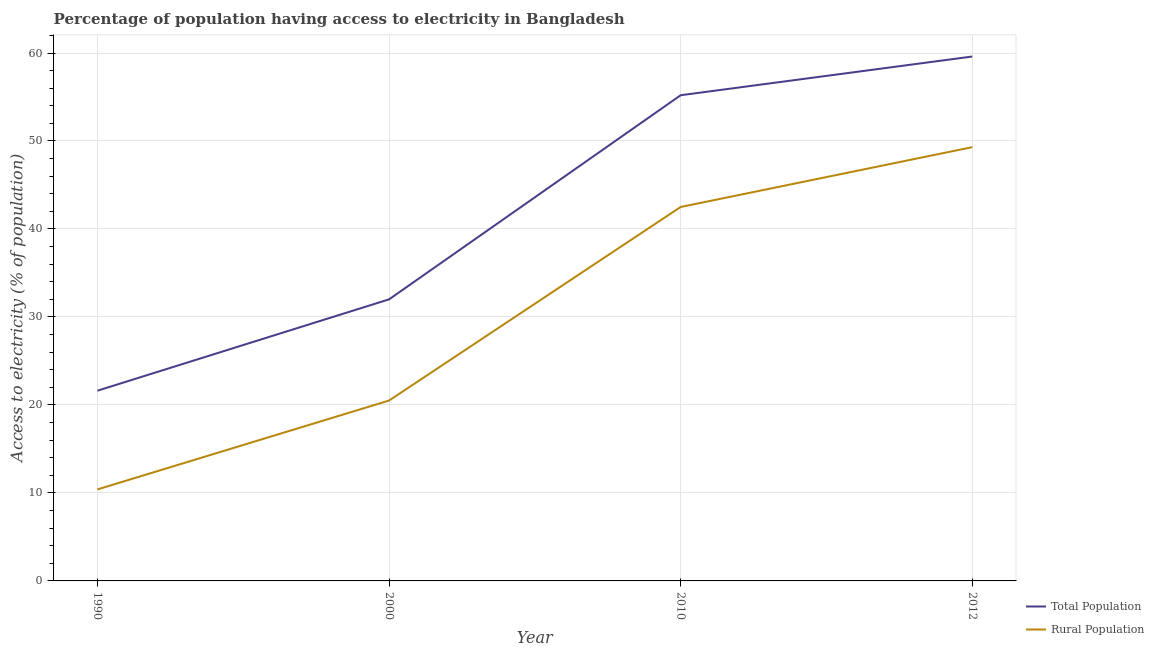Does the line corresponding to percentage of population having access to electricity intersect with the line corresponding to percentage of rural population having access to electricity?
Offer a very short reply. No. Is the number of lines equal to the number of legend labels?
Provide a short and direct response. Yes. Across all years, what is the maximum percentage of population having access to electricity?
Ensure brevity in your answer.  59.6. In which year was the percentage of rural population having access to electricity maximum?
Offer a terse response. 2012. In which year was the percentage of rural population having access to electricity minimum?
Make the answer very short. 1990. What is the total percentage of rural population having access to electricity in the graph?
Provide a short and direct response. 122.7. What is the difference between the percentage of population having access to electricity in 2010 and the percentage of rural population having access to electricity in 2000?
Offer a terse response. 34.7. What is the average percentage of population having access to electricity per year?
Make the answer very short. 42.11. In the year 1990, what is the difference between the percentage of population having access to electricity and percentage of rural population having access to electricity?
Ensure brevity in your answer.  11.22. In how many years, is the percentage of population having access to electricity greater than 16 %?
Keep it short and to the point. 4. What is the ratio of the percentage of rural population having access to electricity in 1990 to that in 2000?
Provide a succinct answer. 0.51. Is the percentage of rural population having access to electricity in 2000 less than that in 2010?
Provide a succinct answer. Yes. What is the difference between the highest and the second highest percentage of rural population having access to electricity?
Your answer should be very brief. 6.8. What is the difference between the highest and the lowest percentage of population having access to electricity?
Ensure brevity in your answer.  37.98. Does the percentage of population having access to electricity monotonically increase over the years?
Give a very brief answer. Yes. Is the percentage of population having access to electricity strictly less than the percentage of rural population having access to electricity over the years?
Make the answer very short. No. How many years are there in the graph?
Offer a terse response. 4. Does the graph contain any zero values?
Your response must be concise. No. How are the legend labels stacked?
Your answer should be very brief. Vertical. What is the title of the graph?
Your answer should be compact. Percentage of population having access to electricity in Bangladesh. Does "RDB nonconcessional" appear as one of the legend labels in the graph?
Make the answer very short. No. What is the label or title of the X-axis?
Ensure brevity in your answer.  Year. What is the label or title of the Y-axis?
Provide a succinct answer. Access to electricity (% of population). What is the Access to electricity (% of population) of Total Population in 1990?
Make the answer very short. 21.62. What is the Access to electricity (% of population) in Total Population in 2010?
Provide a short and direct response. 55.2. What is the Access to electricity (% of population) in Rural Population in 2010?
Make the answer very short. 42.5. What is the Access to electricity (% of population) in Total Population in 2012?
Offer a very short reply. 59.6. What is the Access to electricity (% of population) of Rural Population in 2012?
Give a very brief answer. 49.3. Across all years, what is the maximum Access to electricity (% of population) of Total Population?
Provide a succinct answer. 59.6. Across all years, what is the maximum Access to electricity (% of population) in Rural Population?
Your answer should be very brief. 49.3. Across all years, what is the minimum Access to electricity (% of population) of Total Population?
Keep it short and to the point. 21.62. Across all years, what is the minimum Access to electricity (% of population) of Rural Population?
Make the answer very short. 10.4. What is the total Access to electricity (% of population) in Total Population in the graph?
Your answer should be very brief. 168.42. What is the total Access to electricity (% of population) in Rural Population in the graph?
Your answer should be compact. 122.7. What is the difference between the Access to electricity (% of population) in Total Population in 1990 and that in 2000?
Ensure brevity in your answer.  -10.38. What is the difference between the Access to electricity (% of population) in Total Population in 1990 and that in 2010?
Provide a short and direct response. -33.58. What is the difference between the Access to electricity (% of population) of Rural Population in 1990 and that in 2010?
Keep it short and to the point. -32.1. What is the difference between the Access to electricity (% of population) of Total Population in 1990 and that in 2012?
Your answer should be compact. -37.98. What is the difference between the Access to electricity (% of population) of Rural Population in 1990 and that in 2012?
Make the answer very short. -38.9. What is the difference between the Access to electricity (% of population) of Total Population in 2000 and that in 2010?
Make the answer very short. -23.2. What is the difference between the Access to electricity (% of population) in Rural Population in 2000 and that in 2010?
Offer a very short reply. -22. What is the difference between the Access to electricity (% of population) of Total Population in 2000 and that in 2012?
Your answer should be very brief. -27.6. What is the difference between the Access to electricity (% of population) of Rural Population in 2000 and that in 2012?
Your answer should be very brief. -28.8. What is the difference between the Access to electricity (% of population) of Total Population in 2010 and that in 2012?
Offer a very short reply. -4.4. What is the difference between the Access to electricity (% of population) in Total Population in 1990 and the Access to electricity (% of population) in Rural Population in 2000?
Provide a succinct answer. 1.12. What is the difference between the Access to electricity (% of population) in Total Population in 1990 and the Access to electricity (% of population) in Rural Population in 2010?
Give a very brief answer. -20.88. What is the difference between the Access to electricity (% of population) of Total Population in 1990 and the Access to electricity (% of population) of Rural Population in 2012?
Offer a very short reply. -27.68. What is the difference between the Access to electricity (% of population) of Total Population in 2000 and the Access to electricity (% of population) of Rural Population in 2010?
Give a very brief answer. -10.5. What is the difference between the Access to electricity (% of population) of Total Population in 2000 and the Access to electricity (% of population) of Rural Population in 2012?
Ensure brevity in your answer.  -17.3. What is the average Access to electricity (% of population) in Total Population per year?
Your response must be concise. 42.1. What is the average Access to electricity (% of population) in Rural Population per year?
Provide a short and direct response. 30.68. In the year 1990, what is the difference between the Access to electricity (% of population) of Total Population and Access to electricity (% of population) of Rural Population?
Make the answer very short. 11.22. In the year 2000, what is the difference between the Access to electricity (% of population) of Total Population and Access to electricity (% of population) of Rural Population?
Your response must be concise. 11.5. What is the ratio of the Access to electricity (% of population) in Total Population in 1990 to that in 2000?
Provide a short and direct response. 0.68. What is the ratio of the Access to electricity (% of population) in Rural Population in 1990 to that in 2000?
Give a very brief answer. 0.51. What is the ratio of the Access to electricity (% of population) of Total Population in 1990 to that in 2010?
Your response must be concise. 0.39. What is the ratio of the Access to electricity (% of population) in Rural Population in 1990 to that in 2010?
Provide a succinct answer. 0.24. What is the ratio of the Access to electricity (% of population) in Total Population in 1990 to that in 2012?
Give a very brief answer. 0.36. What is the ratio of the Access to electricity (% of population) of Rural Population in 1990 to that in 2012?
Provide a short and direct response. 0.21. What is the ratio of the Access to electricity (% of population) of Total Population in 2000 to that in 2010?
Provide a succinct answer. 0.58. What is the ratio of the Access to electricity (% of population) of Rural Population in 2000 to that in 2010?
Give a very brief answer. 0.48. What is the ratio of the Access to electricity (% of population) in Total Population in 2000 to that in 2012?
Make the answer very short. 0.54. What is the ratio of the Access to electricity (% of population) in Rural Population in 2000 to that in 2012?
Offer a terse response. 0.42. What is the ratio of the Access to electricity (% of population) of Total Population in 2010 to that in 2012?
Your response must be concise. 0.93. What is the ratio of the Access to electricity (% of population) of Rural Population in 2010 to that in 2012?
Provide a short and direct response. 0.86. What is the difference between the highest and the second highest Access to electricity (% of population) of Total Population?
Offer a terse response. 4.4. What is the difference between the highest and the second highest Access to electricity (% of population) of Rural Population?
Offer a terse response. 6.8. What is the difference between the highest and the lowest Access to electricity (% of population) of Total Population?
Offer a very short reply. 37.98. What is the difference between the highest and the lowest Access to electricity (% of population) in Rural Population?
Provide a short and direct response. 38.9. 